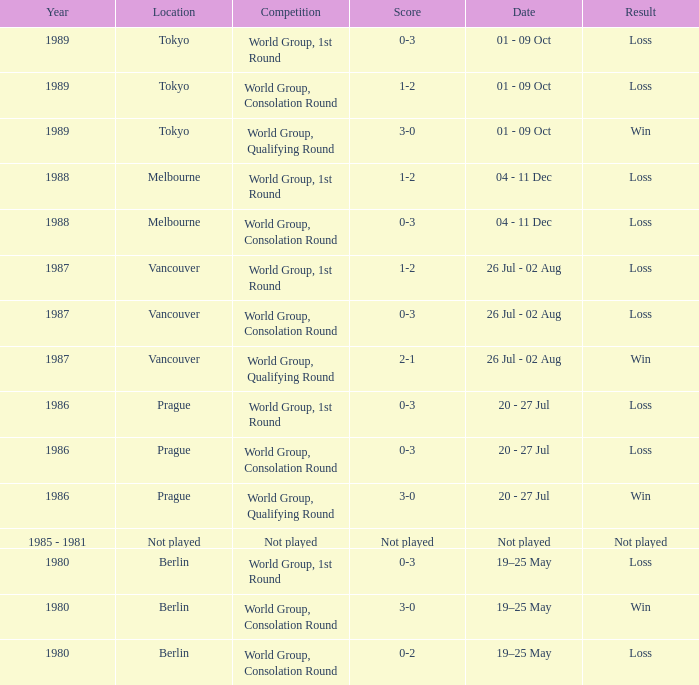What is the score when the result is loss, the year is 1980 and the competition is world group, consolation round? 0-2. 